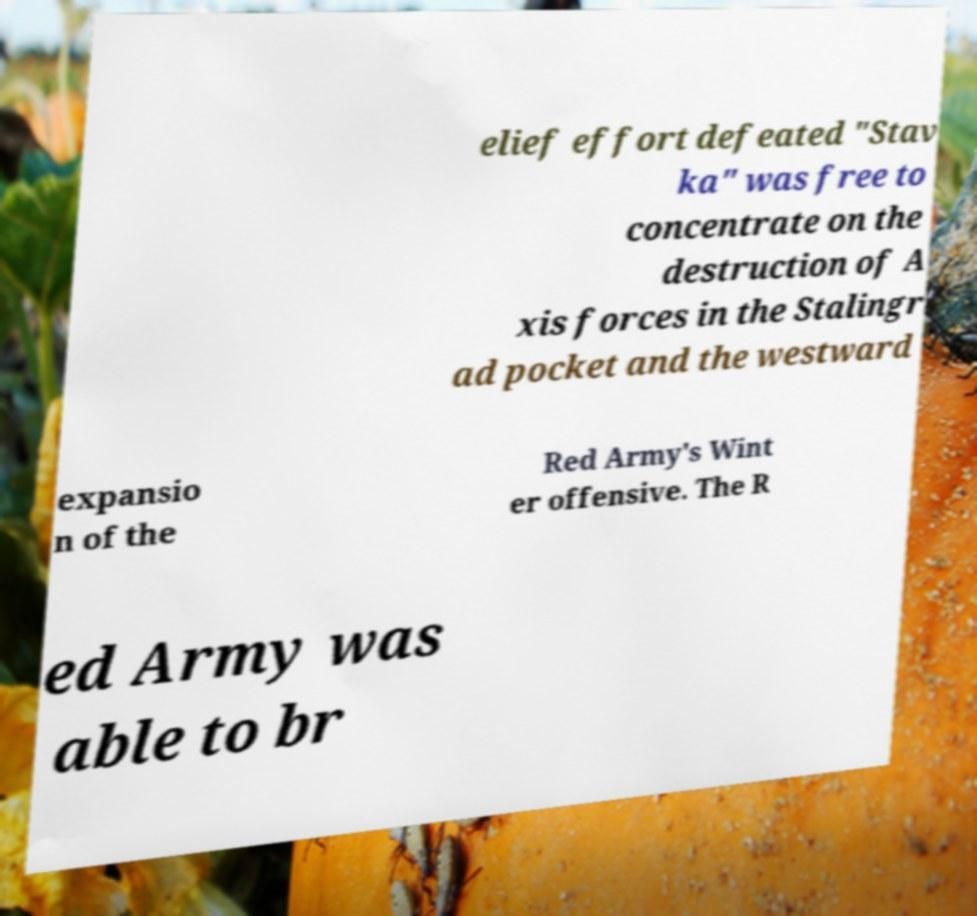Please read and relay the text visible in this image. What does it say? elief effort defeated "Stav ka" was free to concentrate on the destruction of A xis forces in the Stalingr ad pocket and the westward expansio n of the Red Army's Wint er offensive. The R ed Army was able to br 